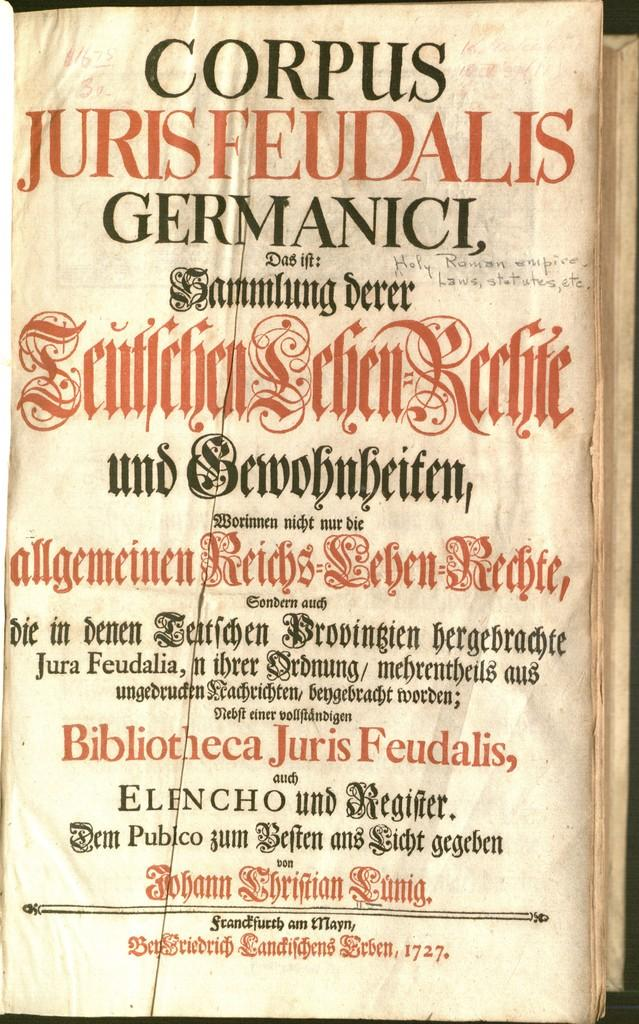<image>
Relay a brief, clear account of the picture shown. The book in the photo is called Corpus JurisFeudalis Germanici. 